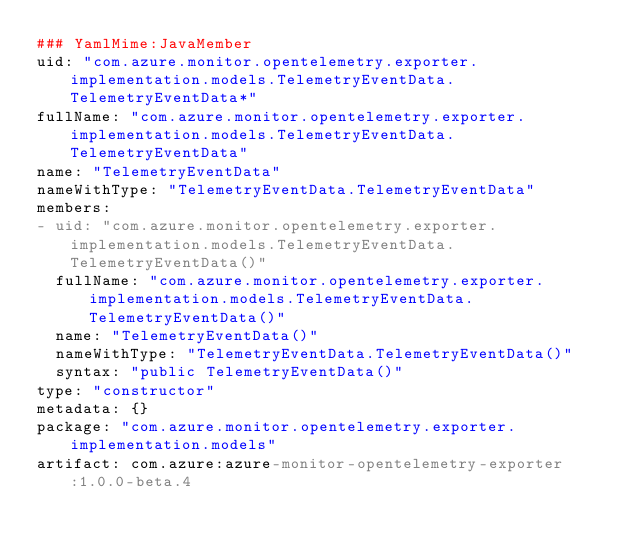<code> <loc_0><loc_0><loc_500><loc_500><_YAML_>### YamlMime:JavaMember
uid: "com.azure.monitor.opentelemetry.exporter.implementation.models.TelemetryEventData.TelemetryEventData*"
fullName: "com.azure.monitor.opentelemetry.exporter.implementation.models.TelemetryEventData.TelemetryEventData"
name: "TelemetryEventData"
nameWithType: "TelemetryEventData.TelemetryEventData"
members:
- uid: "com.azure.monitor.opentelemetry.exporter.implementation.models.TelemetryEventData.TelemetryEventData()"
  fullName: "com.azure.monitor.opentelemetry.exporter.implementation.models.TelemetryEventData.TelemetryEventData()"
  name: "TelemetryEventData()"
  nameWithType: "TelemetryEventData.TelemetryEventData()"
  syntax: "public TelemetryEventData()"
type: "constructor"
metadata: {}
package: "com.azure.monitor.opentelemetry.exporter.implementation.models"
artifact: com.azure:azure-monitor-opentelemetry-exporter:1.0.0-beta.4
</code> 